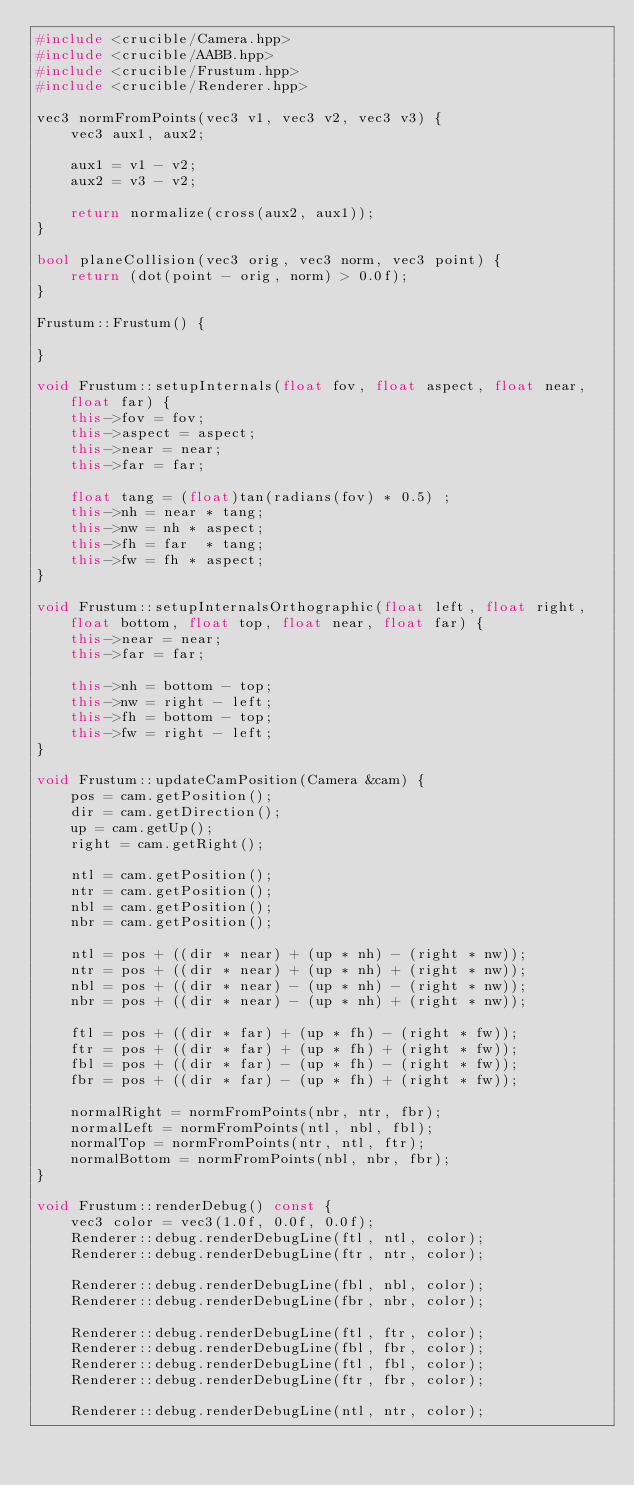<code> <loc_0><loc_0><loc_500><loc_500><_C++_>#include <crucible/Camera.hpp>
#include <crucible/AABB.hpp>
#include <crucible/Frustum.hpp>
#include <crucible/Renderer.hpp>

vec3 normFromPoints(vec3 v1, vec3 v2, vec3 v3) {
    vec3 aux1, aux2;

    aux1 = v1 - v2;
    aux2 = v3 - v2;

    return normalize(cross(aux2, aux1));
}

bool planeCollision(vec3 orig, vec3 norm, vec3 point) {
    return (dot(point - orig, norm) > 0.0f);
}

Frustum::Frustum() {

}

void Frustum::setupInternals(float fov, float aspect, float near, float far) {
    this->fov = fov;
    this->aspect = aspect;
    this->near = near;
    this->far = far;

    float tang = (float)tan(radians(fov) * 0.5) ;
    this->nh = near * tang;
    this->nw = nh * aspect;
    this->fh = far  * tang;
    this->fw = fh * aspect;
}

void Frustum::setupInternalsOrthographic(float left, float right, float bottom, float top, float near, float far) {
    this->near = near;
    this->far = far;

    this->nh = bottom - top;
    this->nw = right - left;
    this->fh = bottom - top;
    this->fw = right - left;
}

void Frustum::updateCamPosition(Camera &cam) {
    pos = cam.getPosition();
    dir = cam.getDirection();
    up = cam.getUp();
    right = cam.getRight();

    ntl = cam.getPosition();
    ntr = cam.getPosition();
    nbl = cam.getPosition();
    nbr = cam.getPosition();

    ntl = pos + ((dir * near) + (up * nh) - (right * nw));
    ntr = pos + ((dir * near) + (up * nh) + (right * nw));
    nbl = pos + ((dir * near) - (up * nh) - (right * nw));
    nbr = pos + ((dir * near) - (up * nh) + (right * nw));

    ftl = pos + ((dir * far) + (up * fh) - (right * fw));
    ftr = pos + ((dir * far) + (up * fh) + (right * fw));
    fbl = pos + ((dir * far) - (up * fh) - (right * fw));
    fbr = pos + ((dir * far) - (up * fh) + (right * fw));

    normalRight = normFromPoints(nbr, ntr, fbr);
    normalLeft = normFromPoints(ntl, nbl, fbl);
    normalTop = normFromPoints(ntr, ntl, ftr);
    normalBottom = normFromPoints(nbl, nbr, fbr);
}

void Frustum::renderDebug() const {
    vec3 color = vec3(1.0f, 0.0f, 0.0f);
    Renderer::debug.renderDebugLine(ftl, ntl, color);
    Renderer::debug.renderDebugLine(ftr, ntr, color);

    Renderer::debug.renderDebugLine(fbl, nbl, color);
    Renderer::debug.renderDebugLine(fbr, nbr, color);

    Renderer::debug.renderDebugLine(ftl, ftr, color);
    Renderer::debug.renderDebugLine(fbl, fbr, color);
    Renderer::debug.renderDebugLine(ftl, fbl, color);
    Renderer::debug.renderDebugLine(ftr, fbr, color);

    Renderer::debug.renderDebugLine(ntl, ntr, color);</code> 